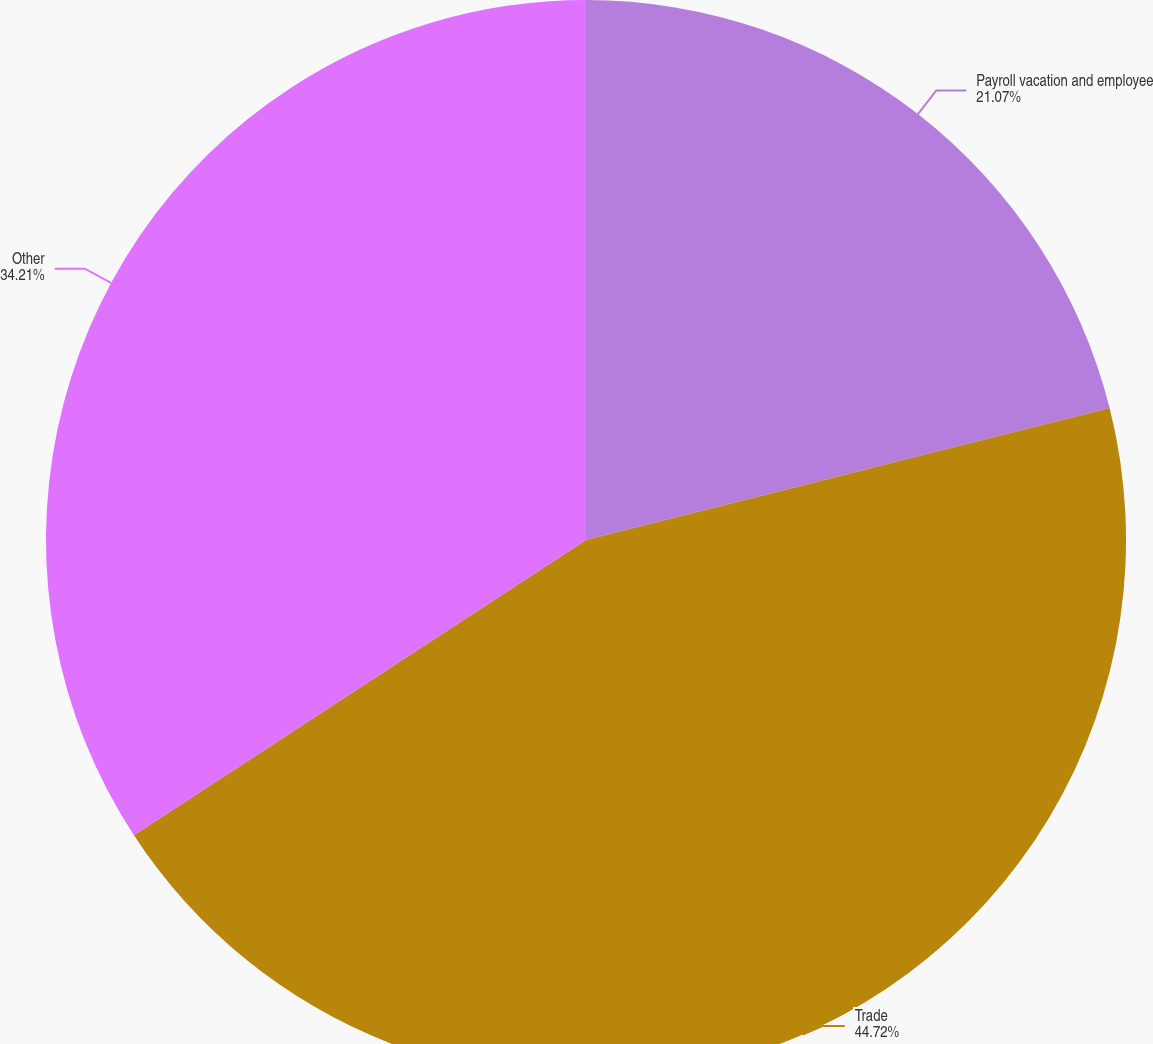Convert chart. <chart><loc_0><loc_0><loc_500><loc_500><pie_chart><fcel>Payroll vacation and employee<fcel>Trade<fcel>Other<nl><fcel>21.07%<fcel>44.72%<fcel>34.21%<nl></chart> 